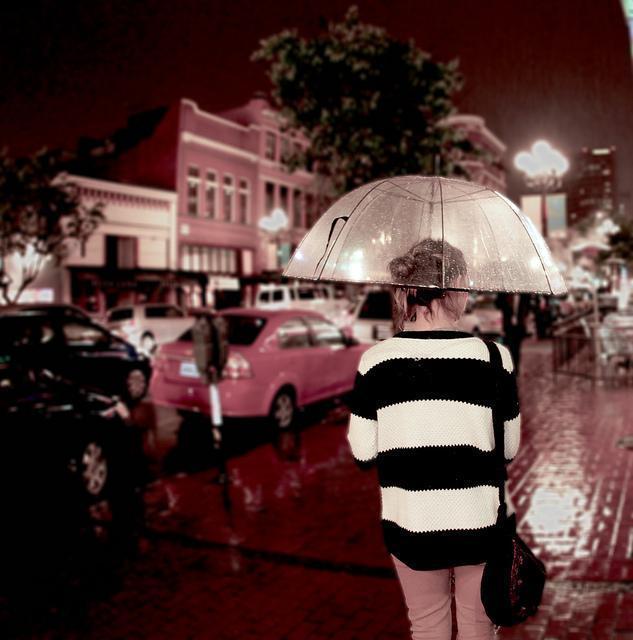How many cars can be seen?
Give a very brief answer. 6. 